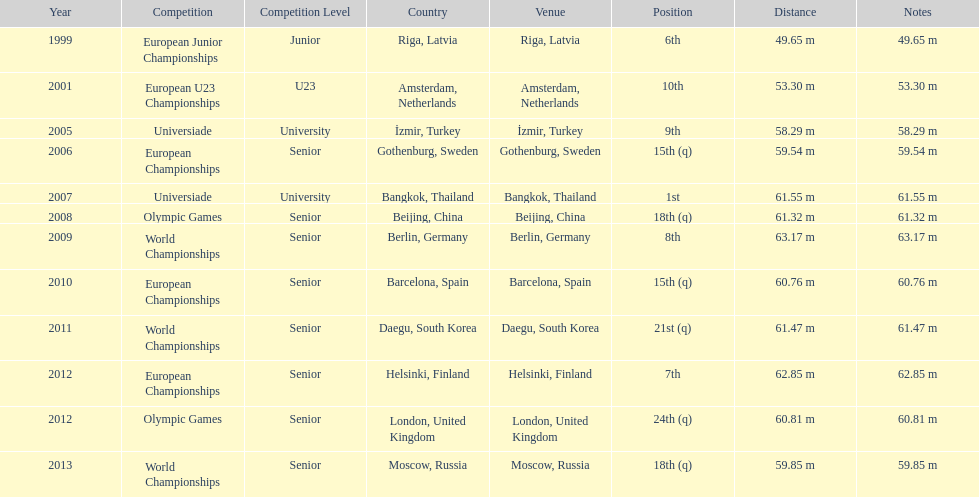During what listed year was the 5 2001. 